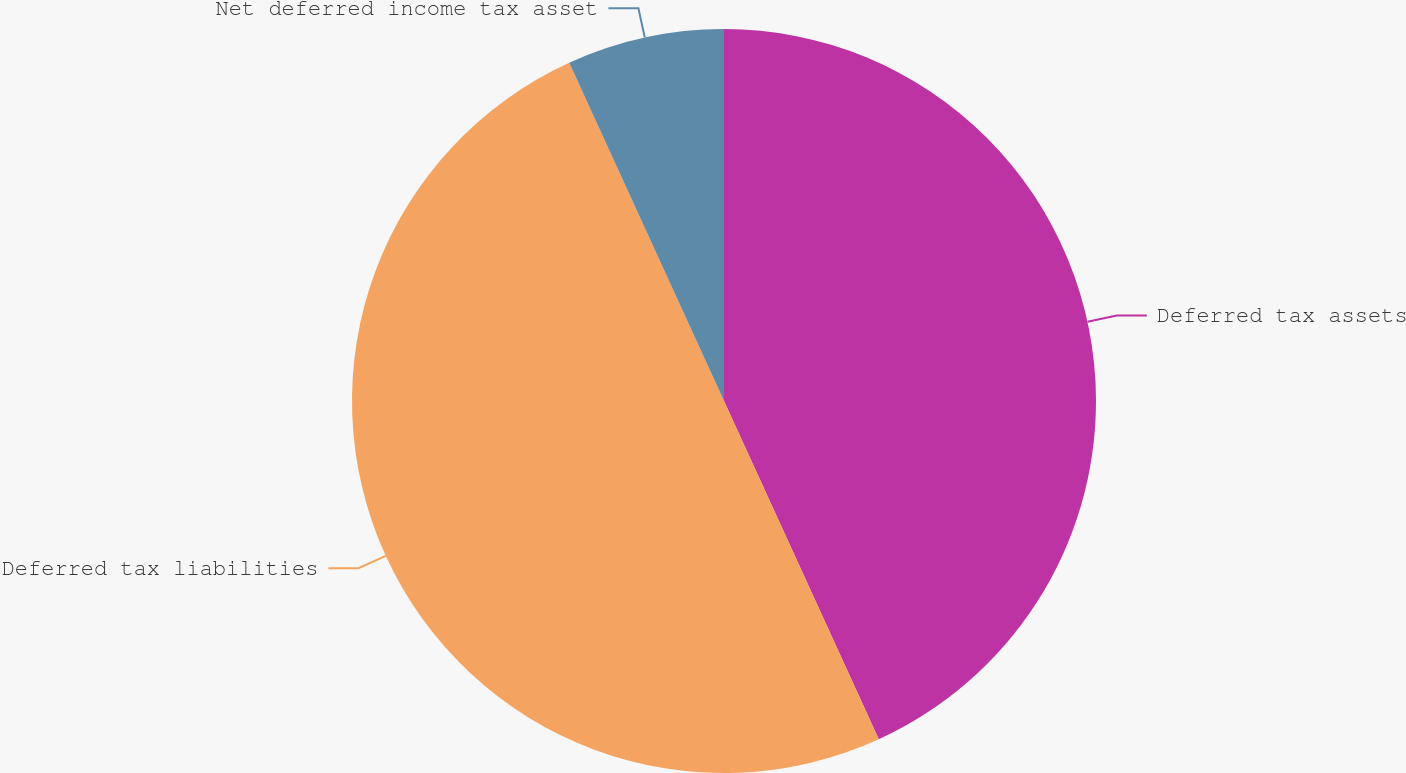Convert chart to OTSL. <chart><loc_0><loc_0><loc_500><loc_500><pie_chart><fcel>Deferred tax assets<fcel>Deferred tax liabilities<fcel>Net deferred income tax asset<nl><fcel>43.17%<fcel>50.0%<fcel>6.83%<nl></chart> 